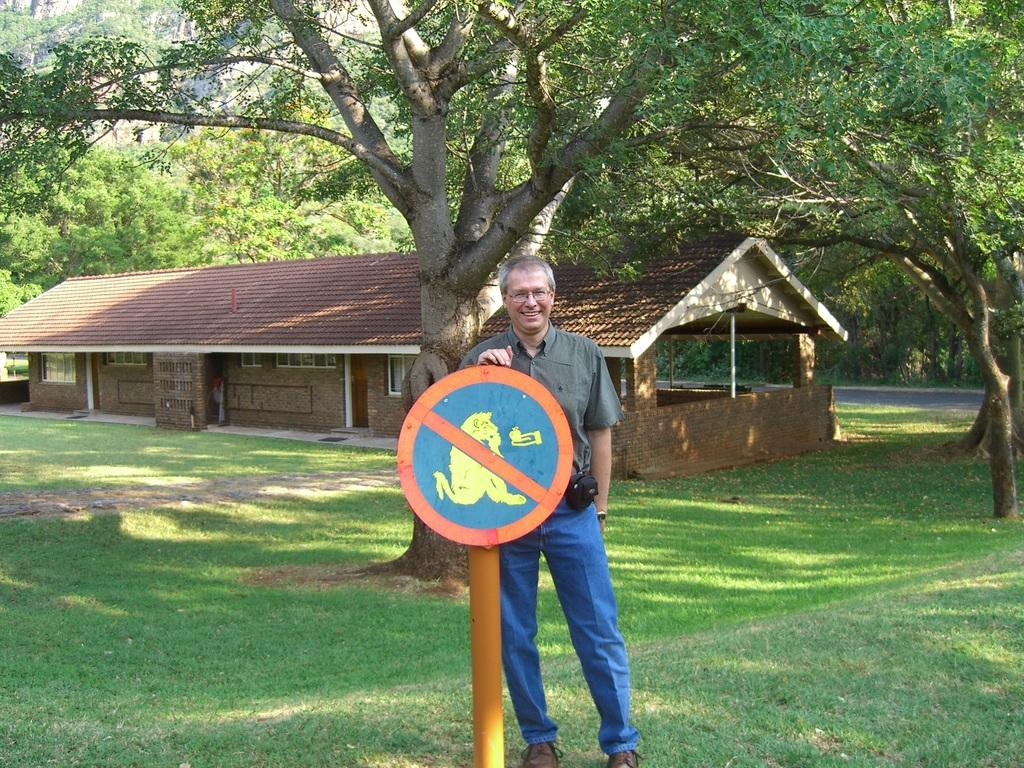What can be seen in the image? There is a person, a pole with a signboard, a house, the ground, grass, and trees in the image. Can you describe the pole with a signboard? Yes, there is a pole with a signboard in the image. What is the condition of the ground in the image? The ground is visible in the image, and there is grass on it. Are there any trees in the image? Yes, there are trees in the image. Is there a scarecrow in the image? No, there is no scarecrow present in the image. What type of bath is the person taking in the image? There is no bath or any indication of bathing in the image. 